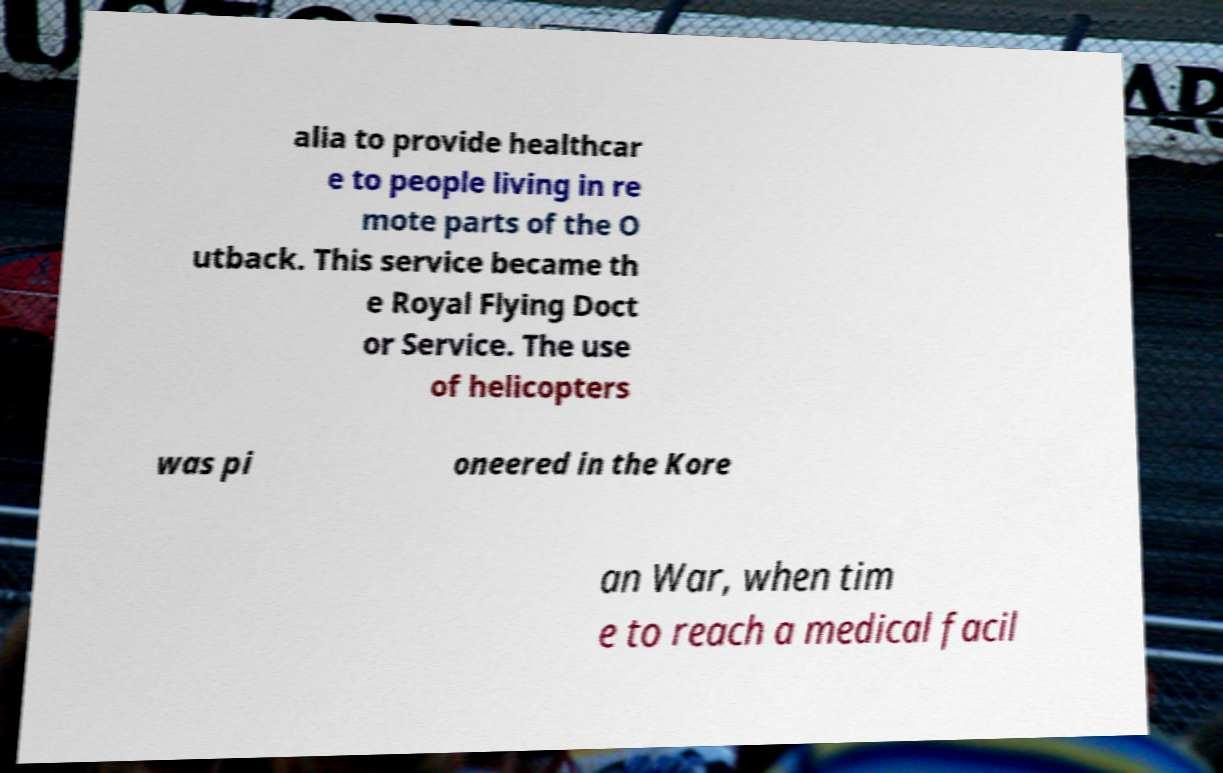Can you read and provide the text displayed in the image?This photo seems to have some interesting text. Can you extract and type it out for me? alia to provide healthcar e to people living in re mote parts of the O utback. This service became th e Royal Flying Doct or Service. The use of helicopters was pi oneered in the Kore an War, when tim e to reach a medical facil 